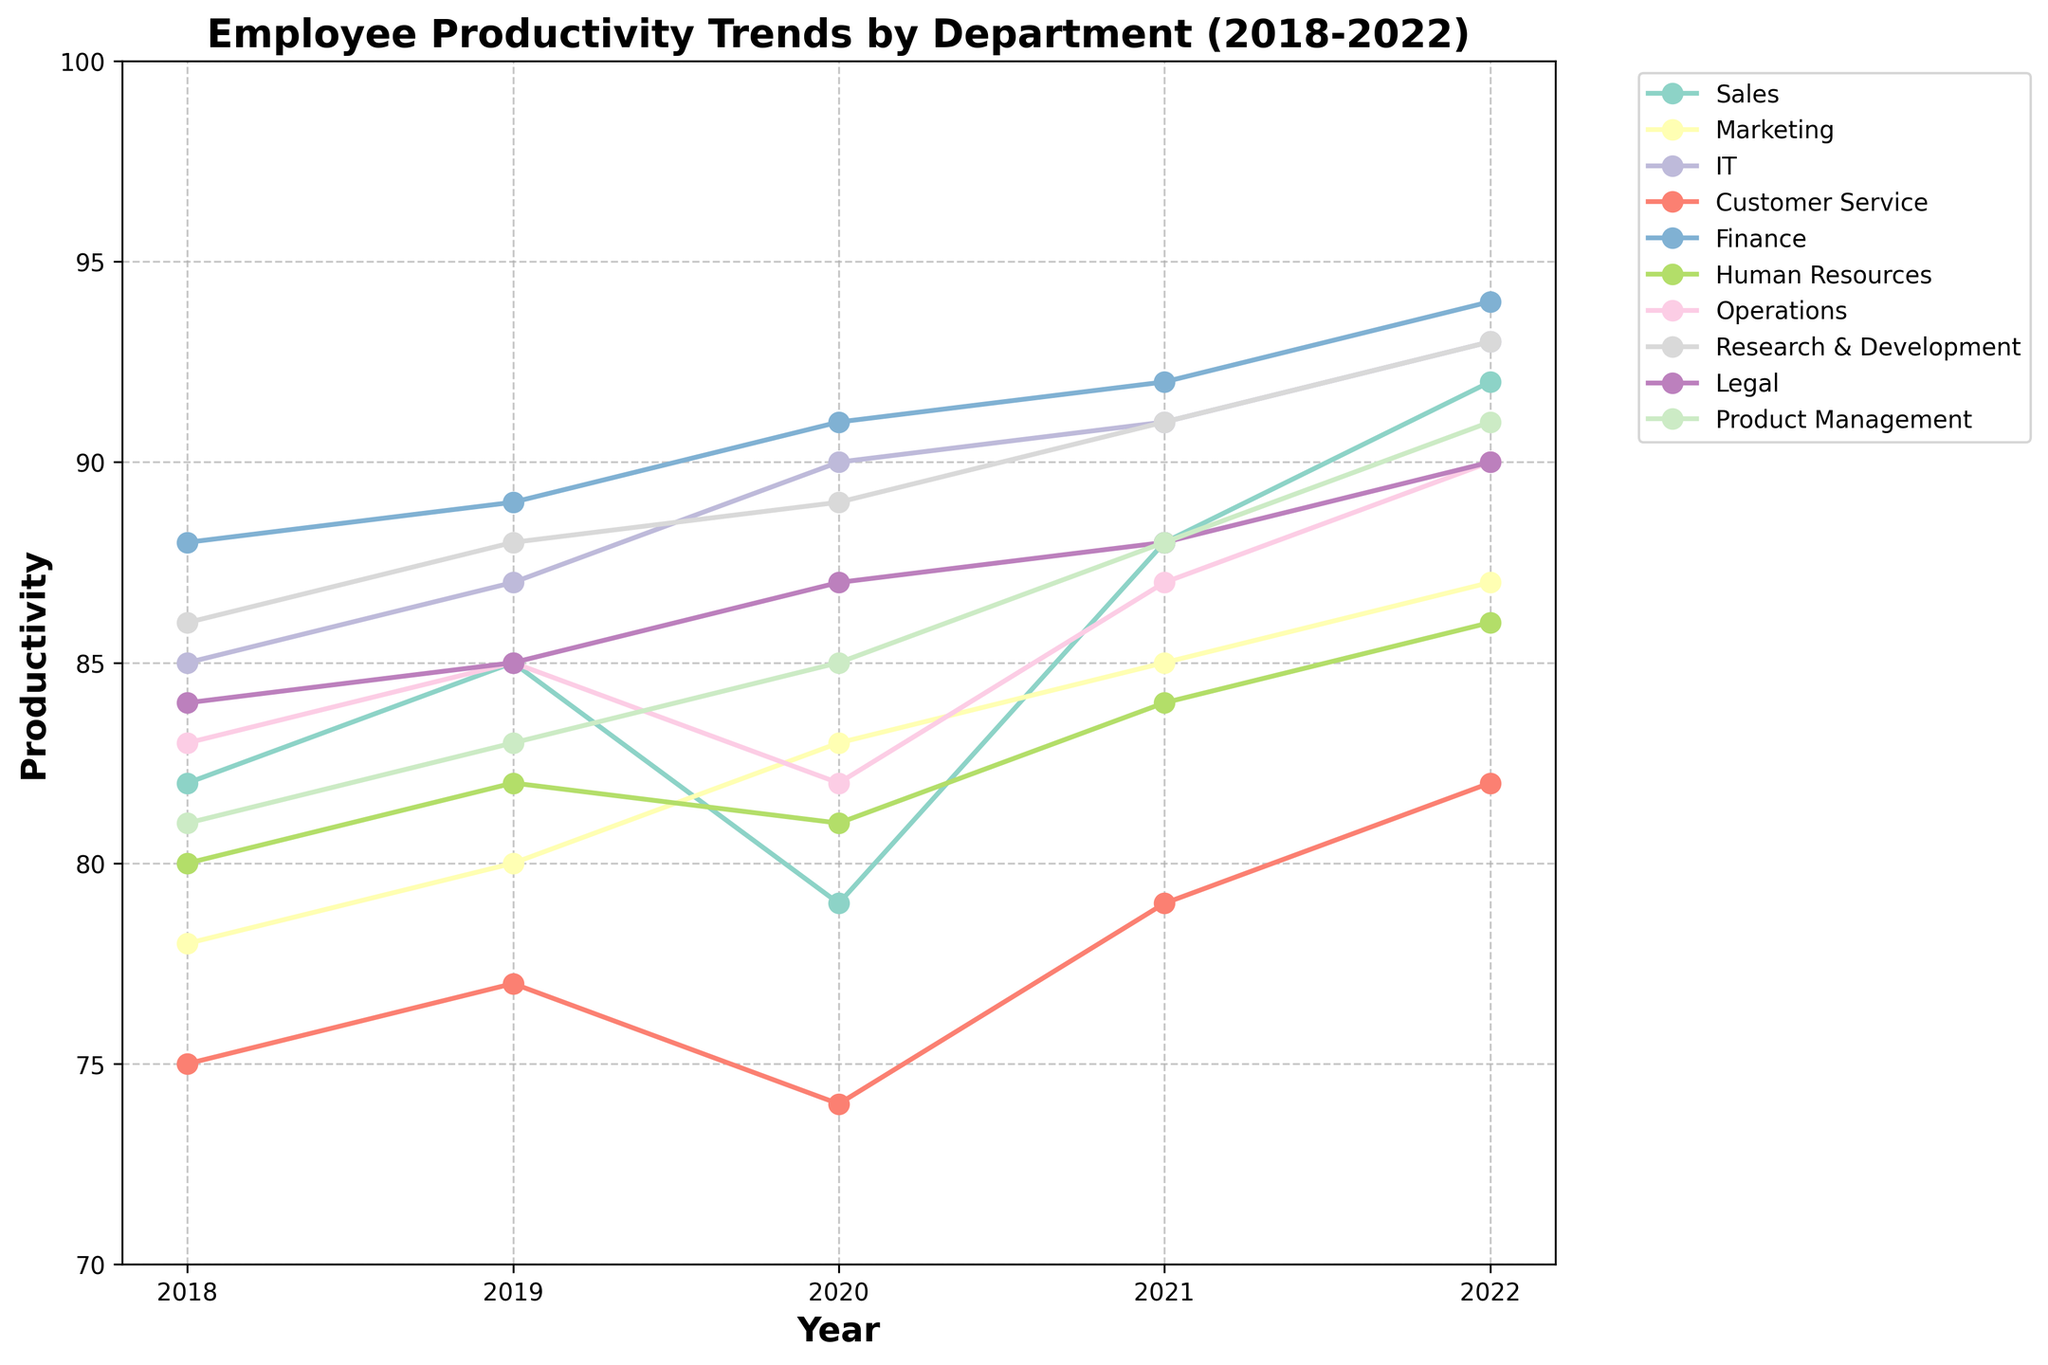Which department showed the most significant increase in productivity from 2018 to 2022? The productivity from 2018 to 2022 for each department is compared. Finance increased from 88 to 94, showing a rise of 6 points.
Answer: Finance Which department had the lowest productivity in 2020? The department with the lowest value in 2020 is identified. Customer Service had a value of 74 in 2020.
Answer: Customer Service What's the average productivity for Marketing over the five years? Adding the productivity values of Marketing for each year (78+80+83+85+87) gives 413. Dividing by 5, the average is 82.6.
Answer: 82.6 Which year saw the highest productivity for the IT department? The maximum productivity value for IT from 2018 to 2022 is observed. The highest value is 93 in 2022.
Answer: 2022 Can we say that all departments had an increasing trend in productivity? Observing the line plots for each department from 2018 to 2022 shows that not all lines are strictly increasing. Only IT and R&D have no dips.
Answer: No Which department had the most volatile productivity trend? Volatility is assessed by the number and size of rises and falls. Customer Service had dips and rises, indicating the most volatility.
Answer: Customer Service Between 2019 and 2021, which department showed the least productivity improvement? Evaluating the change in productivity between 2019 and 2021, Customer Service saw an increase from 77 to 79, an improvement of just 2 points.
Answer: Customer Service How much did productivity change for Operations from 2018 to 2022? Subtracting the 2018 value from the 2022 value for Operations gives 90 - 83 = 7.
Answer: 7 Which departments reached or exceeded a productivity score of 90 in 2022? Observing the 2022 productivity values, the departments are IT, Finance, Operations, R&D, and Product Management.
Answer: IT, Finance, Operations, R&D, Product Management 